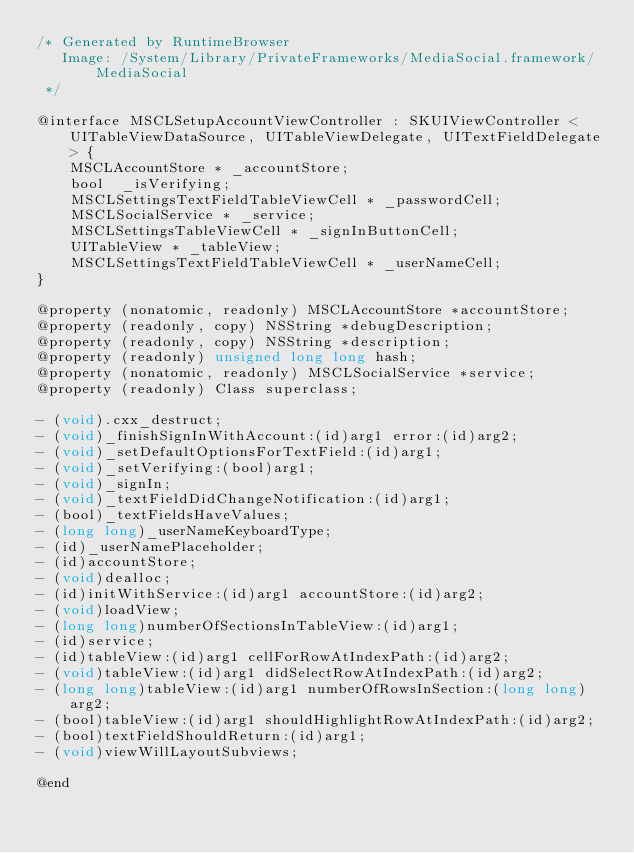Convert code to text. <code><loc_0><loc_0><loc_500><loc_500><_C_>/* Generated by RuntimeBrowser
   Image: /System/Library/PrivateFrameworks/MediaSocial.framework/MediaSocial
 */

@interface MSCLSetupAccountViewController : SKUIViewController <UITableViewDataSource, UITableViewDelegate, UITextFieldDelegate> {
    MSCLAccountStore * _accountStore;
    bool  _isVerifying;
    MSCLSettingsTextFieldTableViewCell * _passwordCell;
    MSCLSocialService * _service;
    MSCLSettingsTableViewCell * _signInButtonCell;
    UITableView * _tableView;
    MSCLSettingsTextFieldTableViewCell * _userNameCell;
}

@property (nonatomic, readonly) MSCLAccountStore *accountStore;
@property (readonly, copy) NSString *debugDescription;
@property (readonly, copy) NSString *description;
@property (readonly) unsigned long long hash;
@property (nonatomic, readonly) MSCLSocialService *service;
@property (readonly) Class superclass;

- (void).cxx_destruct;
- (void)_finishSignInWithAccount:(id)arg1 error:(id)arg2;
- (void)_setDefaultOptionsForTextField:(id)arg1;
- (void)_setVerifying:(bool)arg1;
- (void)_signIn;
- (void)_textFieldDidChangeNotification:(id)arg1;
- (bool)_textFieldsHaveValues;
- (long long)_userNameKeyboardType;
- (id)_userNamePlaceholder;
- (id)accountStore;
- (void)dealloc;
- (id)initWithService:(id)arg1 accountStore:(id)arg2;
- (void)loadView;
- (long long)numberOfSectionsInTableView:(id)arg1;
- (id)service;
- (id)tableView:(id)arg1 cellForRowAtIndexPath:(id)arg2;
- (void)tableView:(id)arg1 didSelectRowAtIndexPath:(id)arg2;
- (long long)tableView:(id)arg1 numberOfRowsInSection:(long long)arg2;
- (bool)tableView:(id)arg1 shouldHighlightRowAtIndexPath:(id)arg2;
- (bool)textFieldShouldReturn:(id)arg1;
- (void)viewWillLayoutSubviews;

@end
</code> 